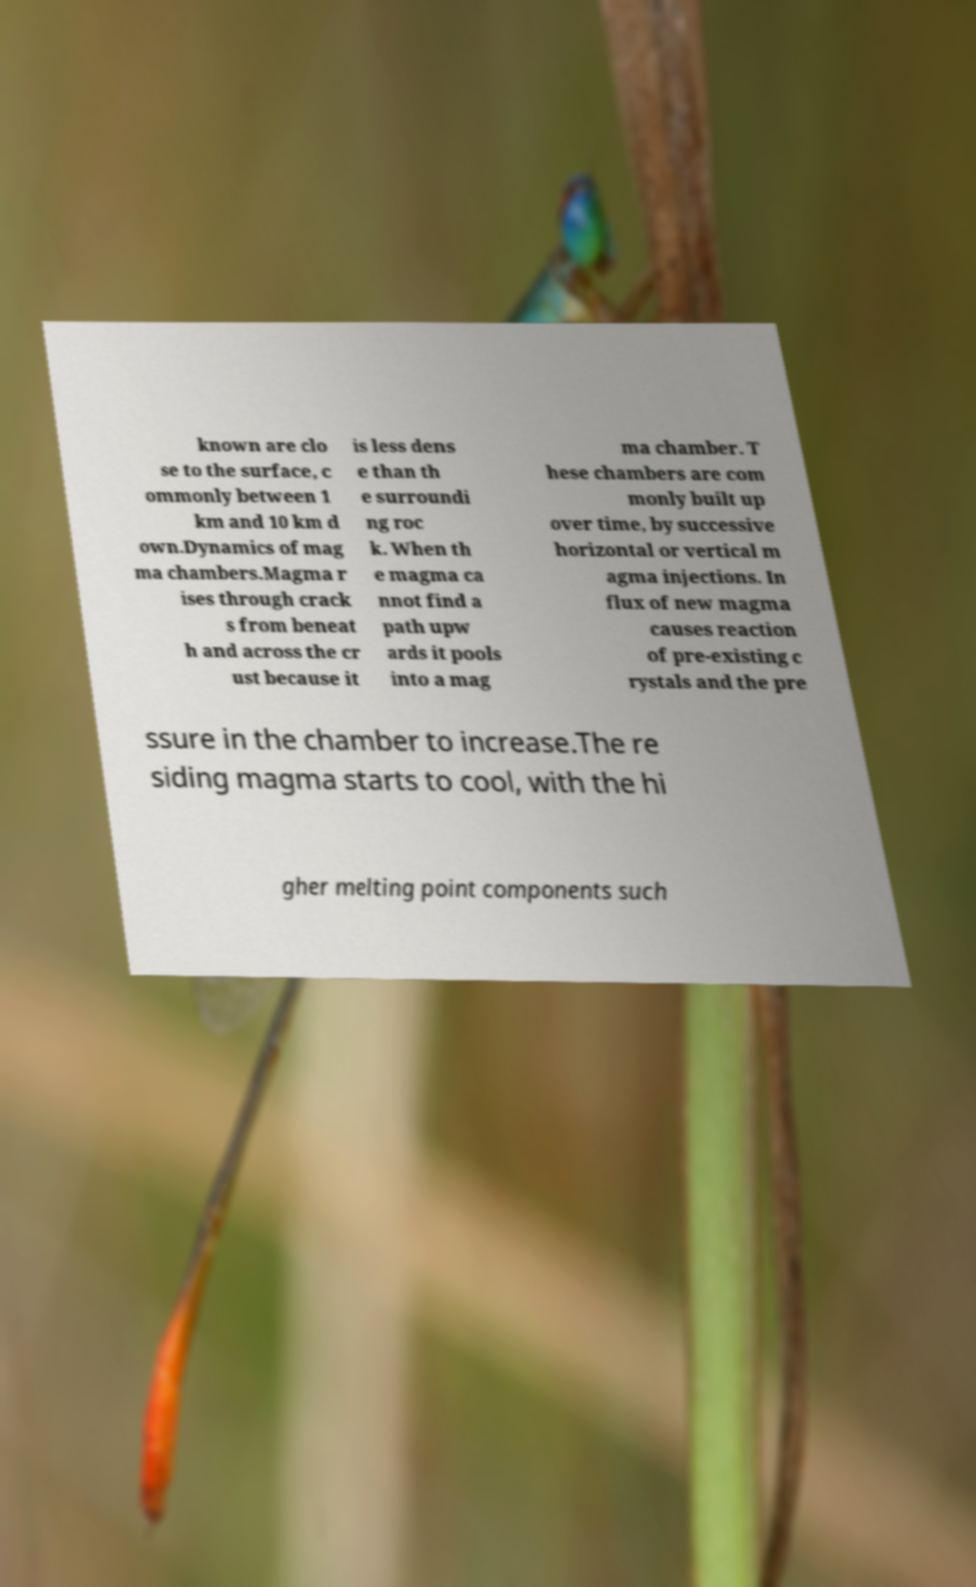What messages or text are displayed in this image? I need them in a readable, typed format. known are clo se to the surface, c ommonly between 1 km and 10 km d own.Dynamics of mag ma chambers.Magma r ises through crack s from beneat h and across the cr ust because it is less dens e than th e surroundi ng roc k. When th e magma ca nnot find a path upw ards it pools into a mag ma chamber. T hese chambers are com monly built up over time, by successive horizontal or vertical m agma injections. In flux of new magma causes reaction of pre-existing c rystals and the pre ssure in the chamber to increase.The re siding magma starts to cool, with the hi gher melting point components such 